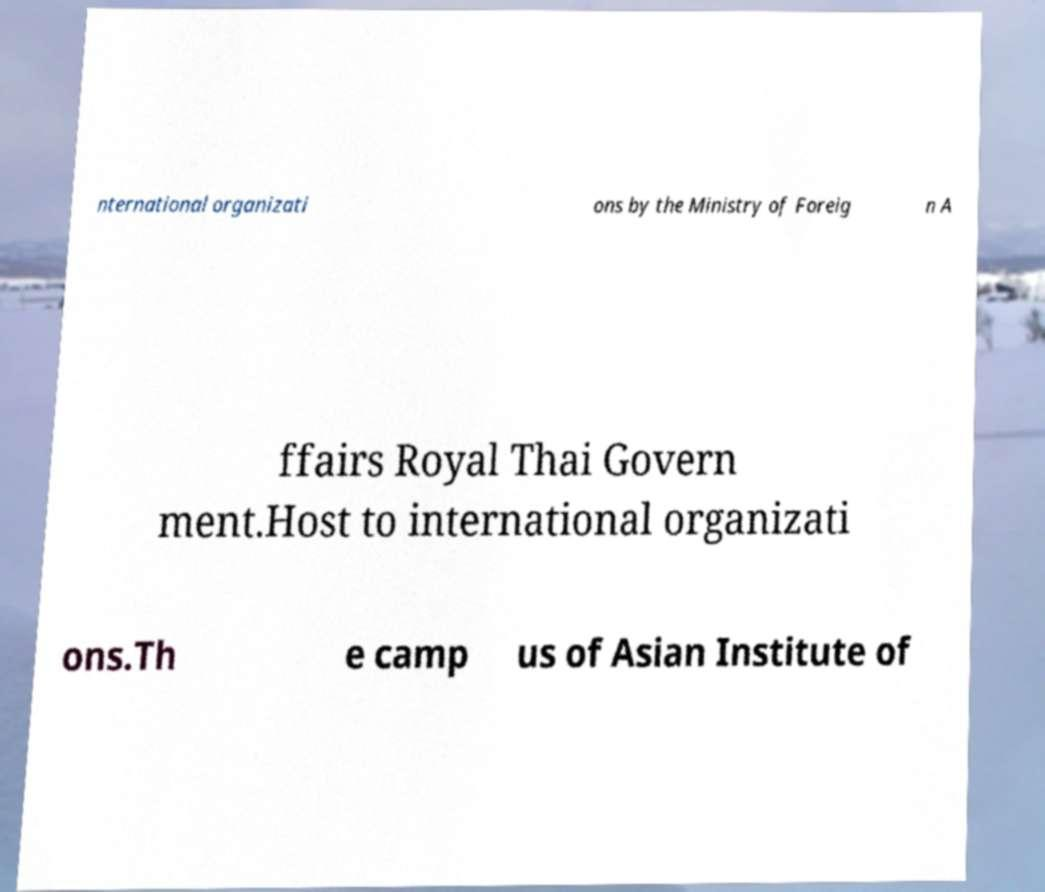What messages or text are displayed in this image? I need them in a readable, typed format. nternational organizati ons by the Ministry of Foreig n A ffairs Royal Thai Govern ment.Host to international organizati ons.Th e camp us of Asian Institute of 